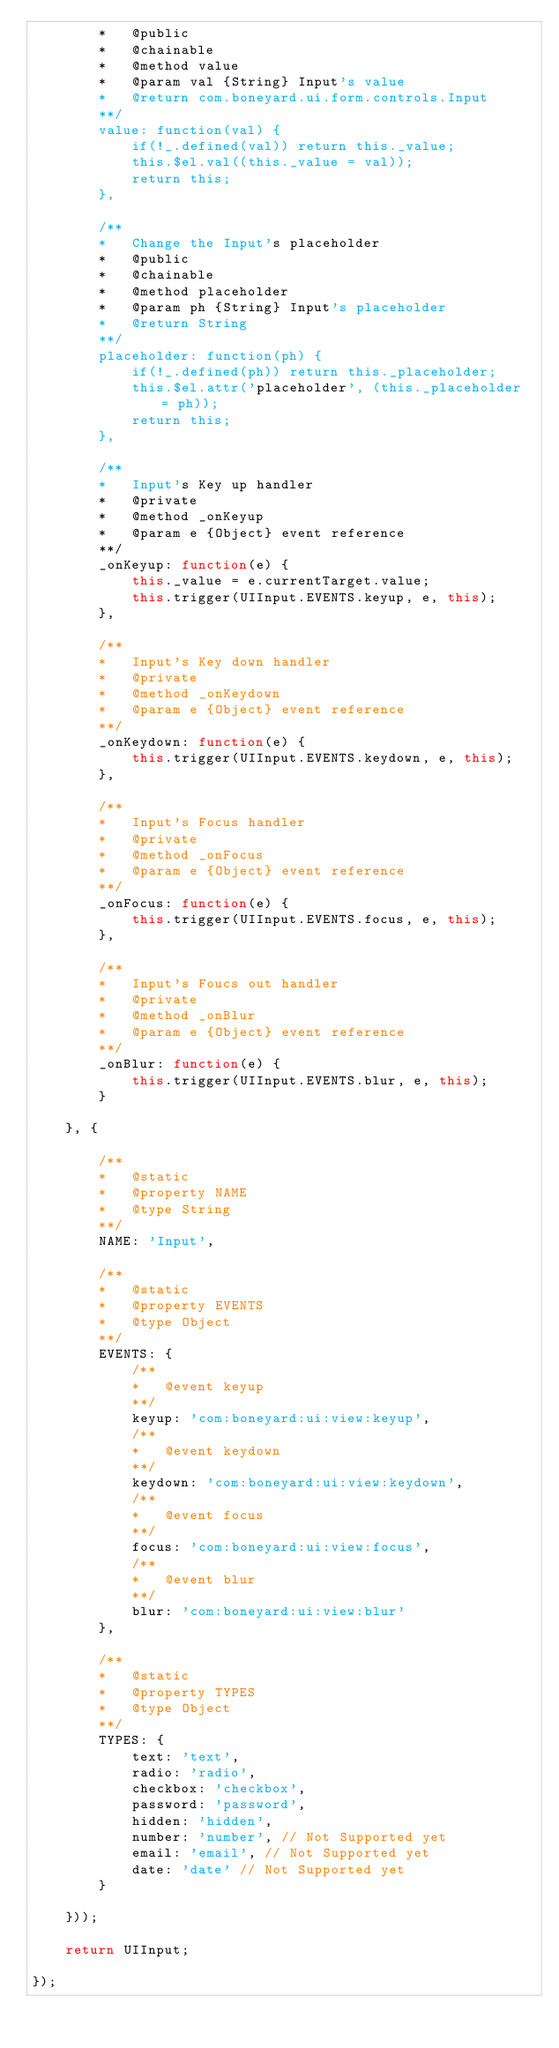<code> <loc_0><loc_0><loc_500><loc_500><_JavaScript_>		*	@public
		*	@chainable
		*	@method value
		*	@param val {String} Input's value
		*	@return com.boneyard.ui.form.controls.Input
		**/
		value: function(val) {
			if(!_.defined(val)) return this._value;
			this.$el.val((this._value = val));
			return this;
		},

		/**
		*	Change the Input's placeholder
		*	@public
		*	@chainable
		*	@method placeholder
		*	@param ph {String} Input's placeholder
		*	@return String
		**/
		placeholder: function(ph) {
			if(!_.defined(ph)) return this._placeholder;
			this.$el.attr('placeholder', (this._placeholder = ph));
			return this;
		},

		/**
		*	Input's Key up handler
		*	@private
		*	@method _onKeyup
		*	@param e {Object} event reference
		**/
		_onKeyup: function(e) {
			this._value = e.currentTarget.value;
			this.trigger(UIInput.EVENTS.keyup, e, this);
		},

		/**
		*	Input's Key down handler
		*	@private
		*	@method _onKeydown
		*	@param e {Object} event reference
		**/
		_onKeydown: function(e) {
			this.trigger(UIInput.EVENTS.keydown, e, this);
		},

		/**
		*	Input's Focus handler
		*	@private
		*	@method _onFocus
		*	@param e {Object} event reference
		**/
		_onFocus: function(e) {
			this.trigger(UIInput.EVENTS.focus, e, this);
		},

		/**
		*	Input's Foucs out handler
		*	@private
		*	@method _onBlur
		*	@param e {Object} event reference
		**/
		_onBlur: function(e) {
			this.trigger(UIInput.EVENTS.blur, e, this);
		}

	}, {

		/**
		*	@static
		*	@property NAME
		*	@type String
		**/
		NAME: 'Input',

		/**
		*	@static
		*	@property EVENTS
		*	@type Object
		**/
		EVENTS: {
			/**
			*	@event keyup
			**/
			keyup: 'com:boneyard:ui:view:keyup',
			/**
			*	@event keydown
			**/
			keydown: 'com:boneyard:ui:view:keydown',
			/**
			*	@event focus
			**/
			focus: 'com:boneyard:ui:view:focus',
			/**
			*	@event blur
			**/
			blur: 'com:boneyard:ui:view:blur'
		},

		/**
		*	@static
		*	@property TYPES
		*	@type Object
		**/
		TYPES: {
			text: 'text',
			radio: 'radio',
			checkbox: 'checkbox',
			password: 'password',
			hidden: 'hidden',
			number: 'number', // Not Supported yet
			email: 'email', // Not Supported yet
			date: 'date' // Not Supported yet
		}

	}));

	return UIInput;

});
</code> 